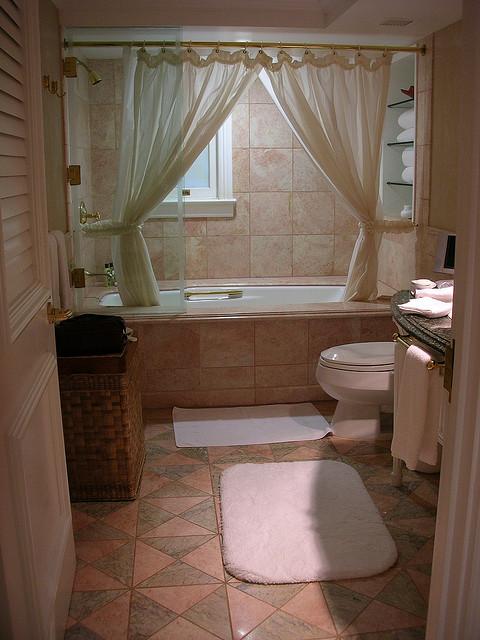What style is the pattern on the wall?
Quick response, please. Tiled. What color is the rug?
Write a very short answer. White. Is this room a bedroom or bathroom?
Concise answer only. Bathroom. Is the room clean or dirty?
Give a very brief answer. Clean. What room is this?
Give a very brief answer. Bathroom. What color is the bathtub?
Answer briefly. White. Is this a half bathroom?
Answer briefly. No. 